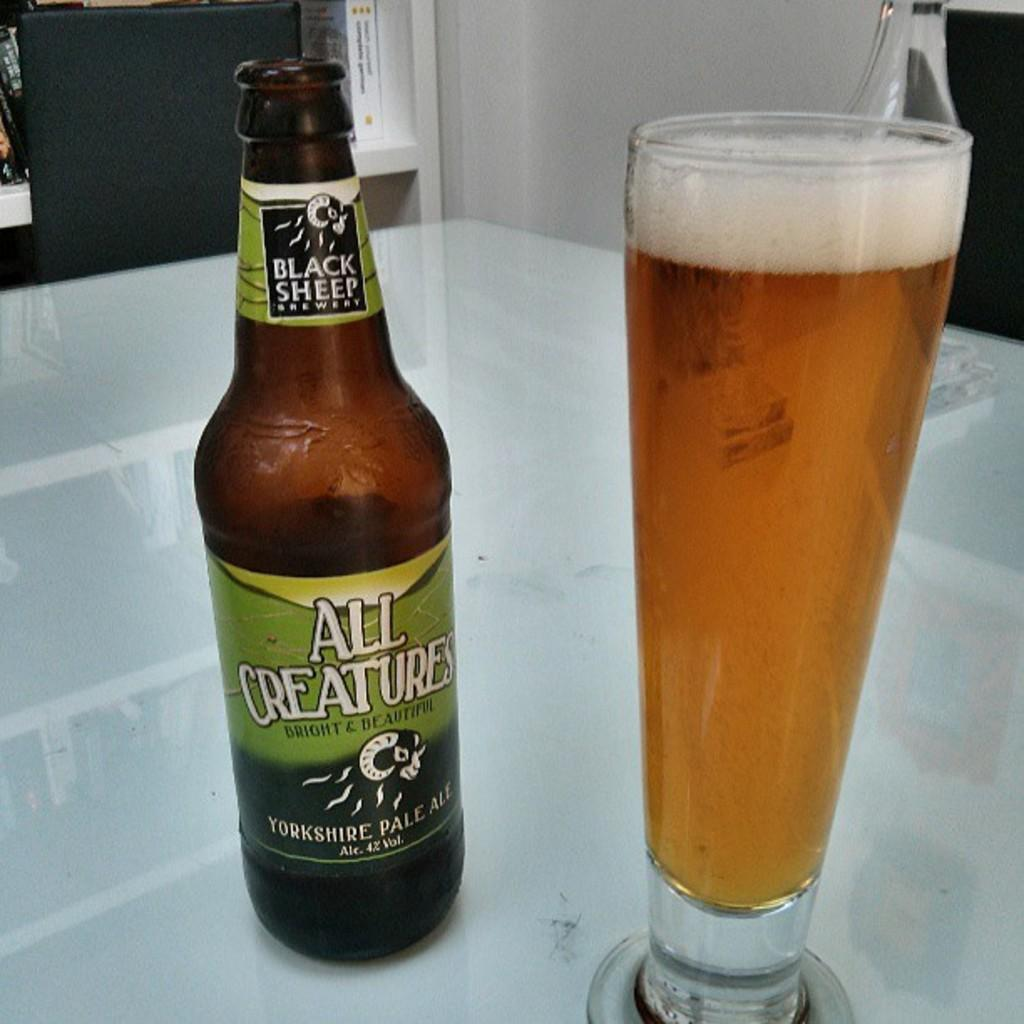<image>
Render a clear and concise summary of the photo. a bottle of black sheep all creatures bright and beautiful yorkshire pale ale 